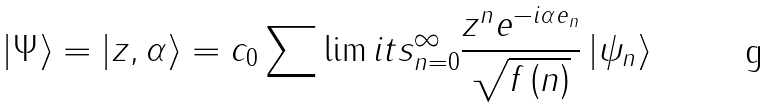Convert formula to latex. <formula><loc_0><loc_0><loc_500><loc_500>\left | \Psi \right \rangle = \left | z , \alpha \right \rangle = c _ { 0 } \sum \lim i t s _ { n = 0 } ^ { \infty } \frac { z ^ { n } e ^ { - i \alpha e _ { n } } } { \sqrt { f \left ( n \right ) } } \left | \psi _ { n } \right \rangle</formula> 